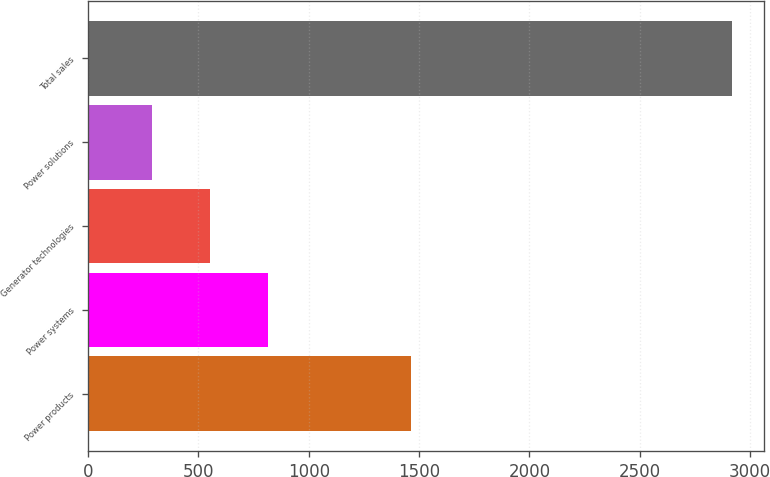Convert chart. <chart><loc_0><loc_0><loc_500><loc_500><bar_chart><fcel>Power products<fcel>Power systems<fcel>Generator technologies<fcel>Power solutions<fcel>Total sales<nl><fcel>1465<fcel>814.2<fcel>551.1<fcel>288<fcel>2919<nl></chart> 